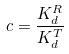<formula> <loc_0><loc_0><loc_500><loc_500>c = \frac { K _ { d } ^ { R } } { K _ { d } ^ { T } }</formula> 